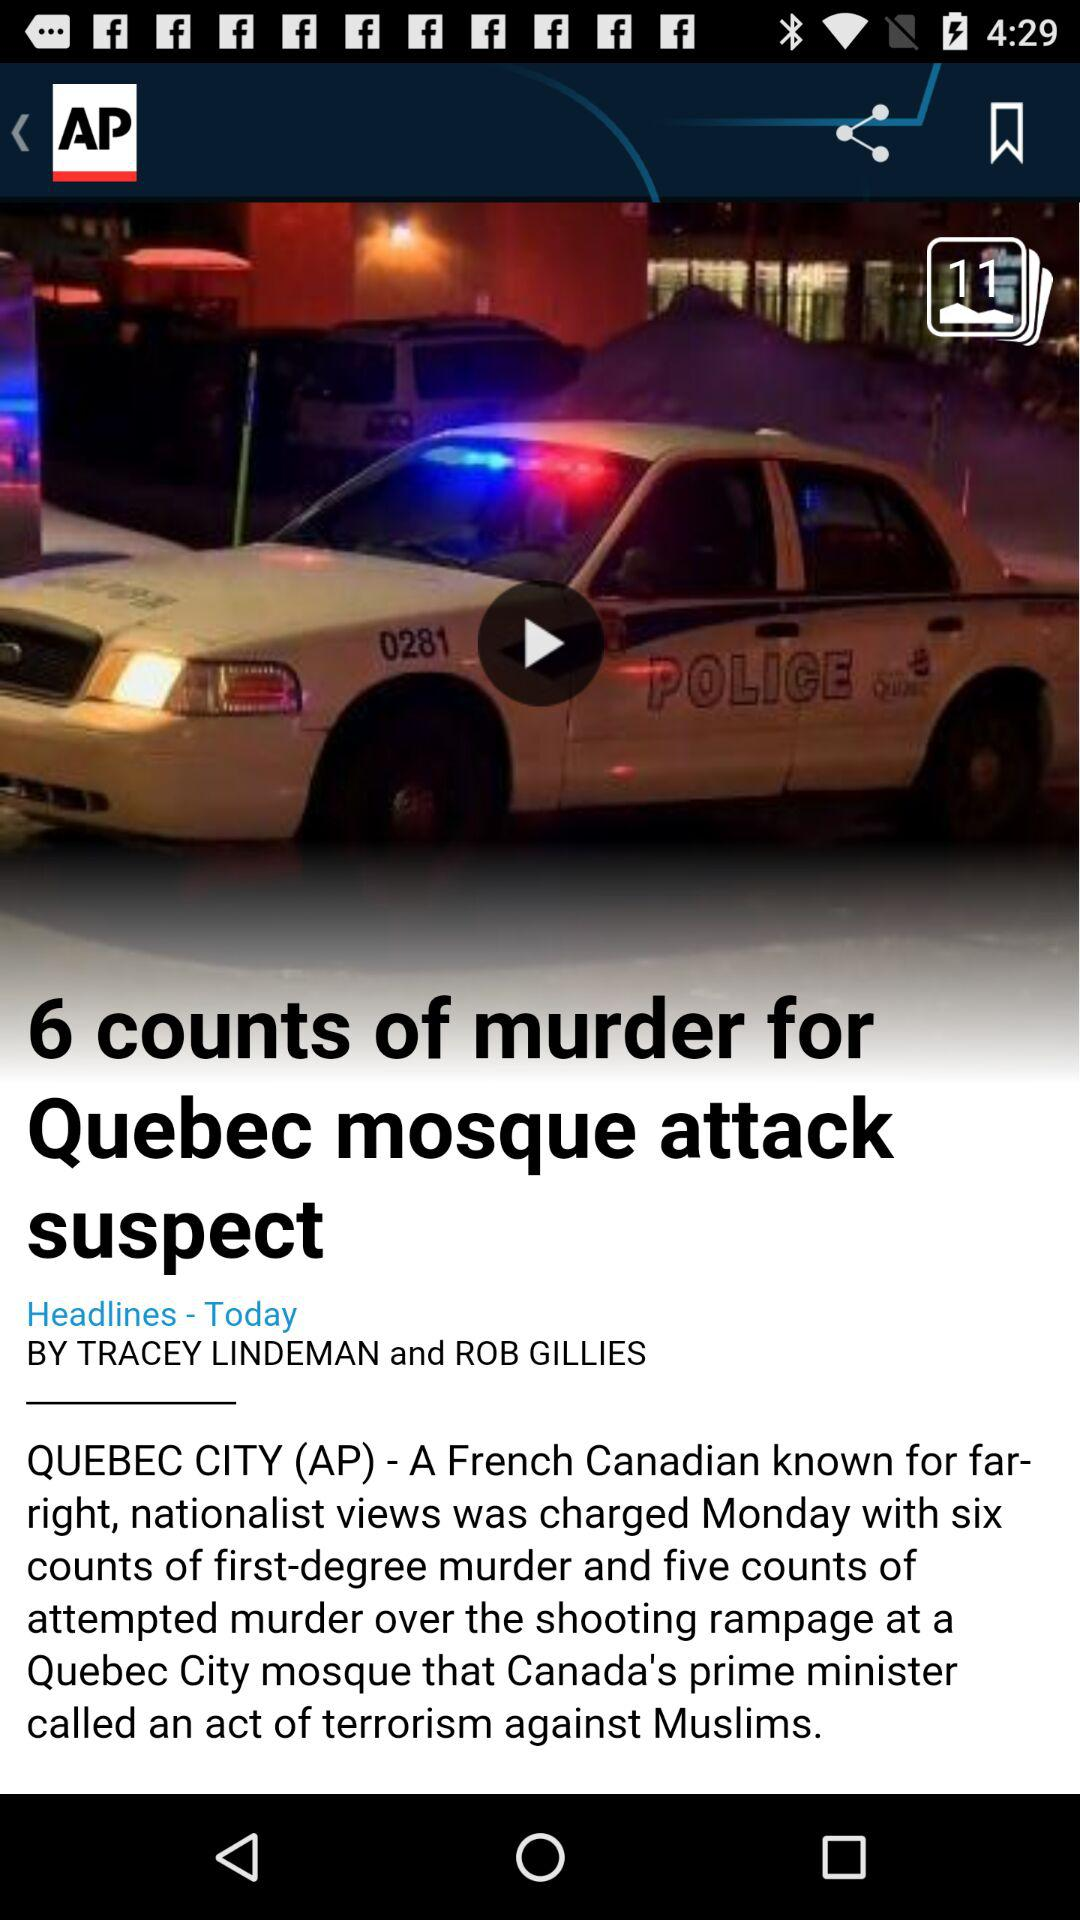What is the headline of the news? The headline of the news is "6 counts of murder for Quebec mosque attack suspect". 